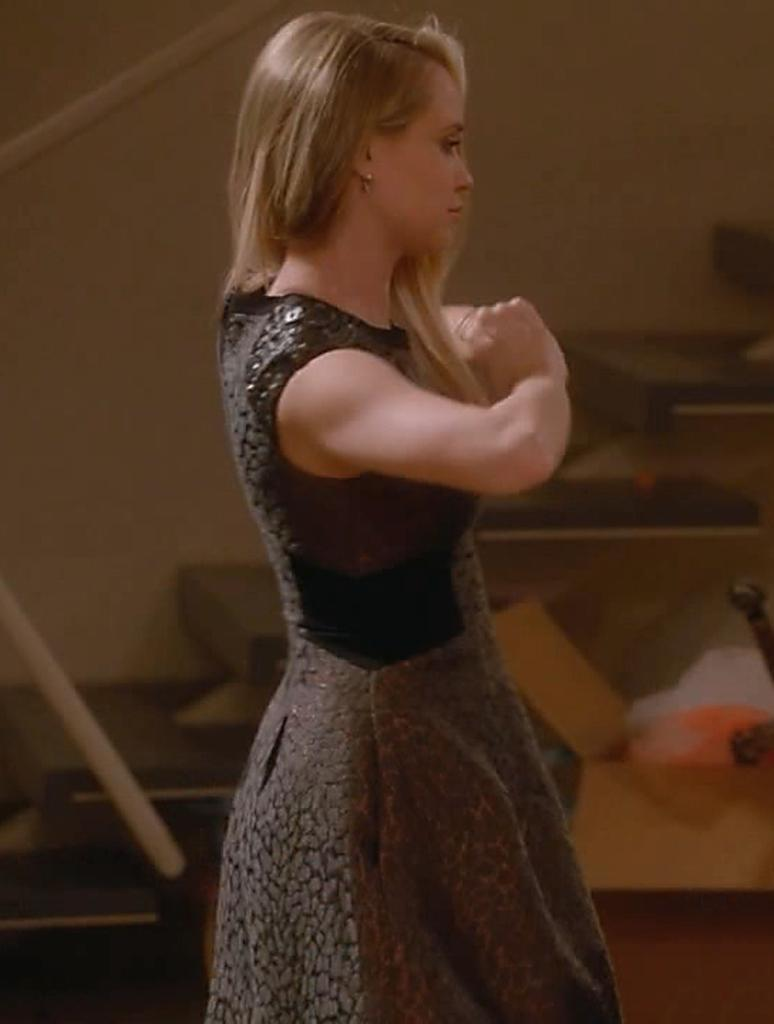What is the main subject of the image? There is a woman standing in the image. Can you describe any objects or items in the background? There is a carton present at the back of the image. What historical event is the woman referring to in the image? There is no indication of any historical event or reference in the image. 